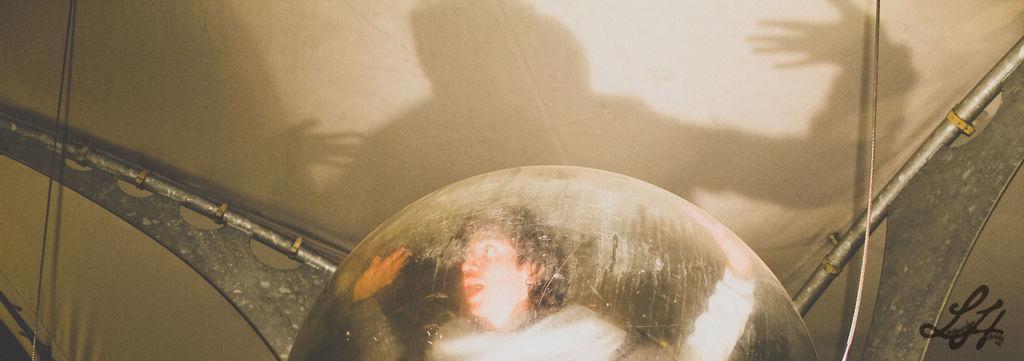How would you summarize this image in a sentence or two? In this image at the bottom there is one ball, on that ball there is one persons reflection, and on the right side and left side there are some poles and ropes. In the background there is a cloth and some shadow. 